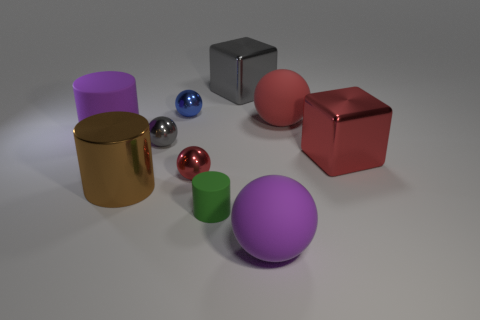Subtract all yellow spheres. Subtract all red cylinders. How many spheres are left? 5 Subtract all cylinders. How many objects are left? 7 Add 3 big blue objects. How many big blue objects exist? 3 Subtract 1 gray blocks. How many objects are left? 9 Subtract all large blocks. Subtract all big yellow metallic cylinders. How many objects are left? 8 Add 1 big red metal things. How many big red metal things are left? 2 